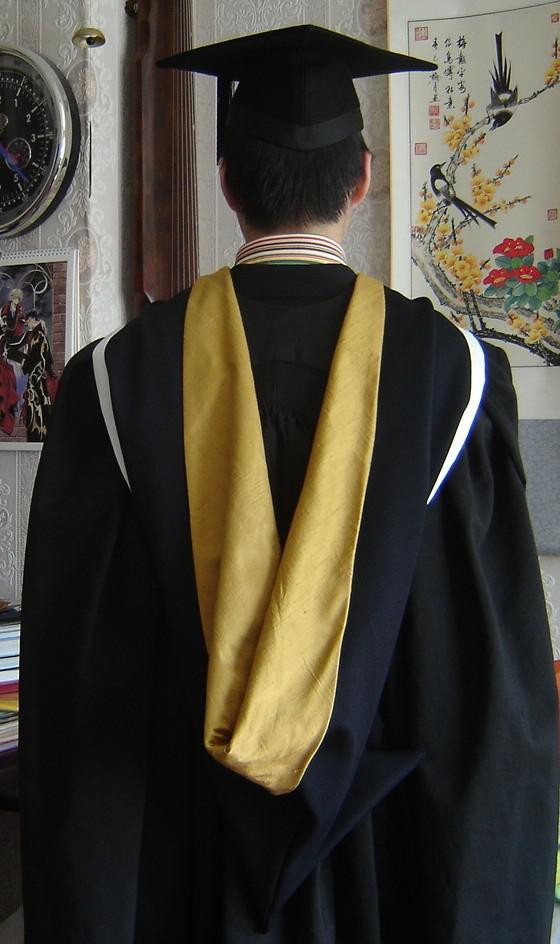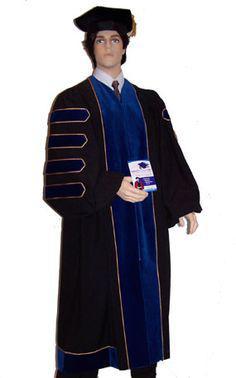The first image is the image on the left, the second image is the image on the right. Evaluate the accuracy of this statement regarding the images: "One person is wearing red.". Is it true? Answer yes or no. No. 